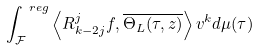Convert formula to latex. <formula><loc_0><loc_0><loc_500><loc_500>\int _ { \mathcal { F } } ^ { \ r e g } \left \langle R _ { k - 2 j } ^ { j } f , \overline { \Theta _ { L } ( \tau , z ) } \right \rangle v ^ { k } d \mu ( \tau )</formula> 